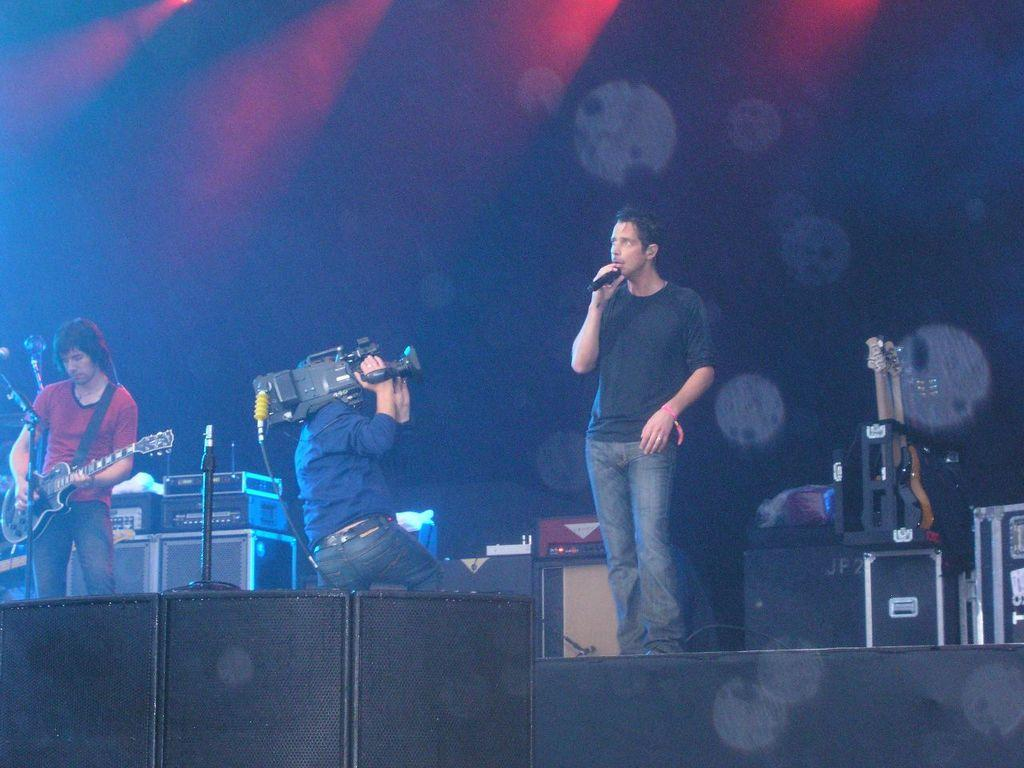How many people are in the image? There are two men in the image. What are the men holding in the image? One man is holding a guitar, and the other man is holding a microphone. Can you describe the person holding a camera in the image? There is a person holding a camera in the image. What is the wealth status of the person holding the camera in the image? There is no information about the wealth status of the person holding the camera in the image. What decision is the man holding the guitar making in the image? There is no information about any decision being made by the man holding the guitar in the image. 